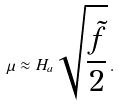Convert formula to latex. <formula><loc_0><loc_0><loc_500><loc_500>\mu \approx H _ { a } \sqrt { \frac { \tilde { f } } { 2 } } \, .</formula> 